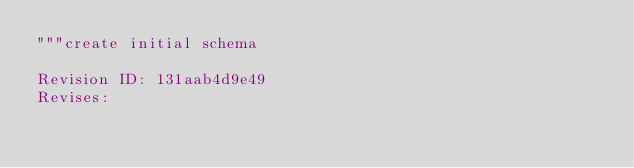<code> <loc_0><loc_0><loc_500><loc_500><_Python_>"""create initial schema

Revision ID: 131aab4d9e49
Revises: </code> 